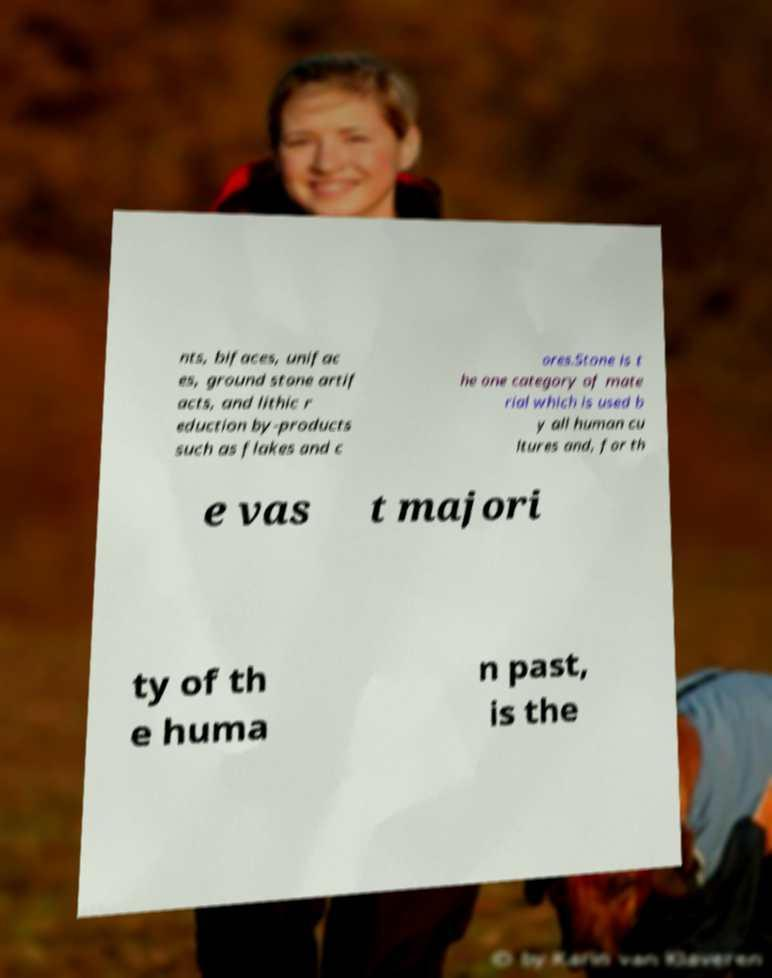Could you assist in decoding the text presented in this image and type it out clearly? nts, bifaces, unifac es, ground stone artif acts, and lithic r eduction by-products such as flakes and c ores.Stone is t he one category of mate rial which is used b y all human cu ltures and, for th e vas t majori ty of th e huma n past, is the 